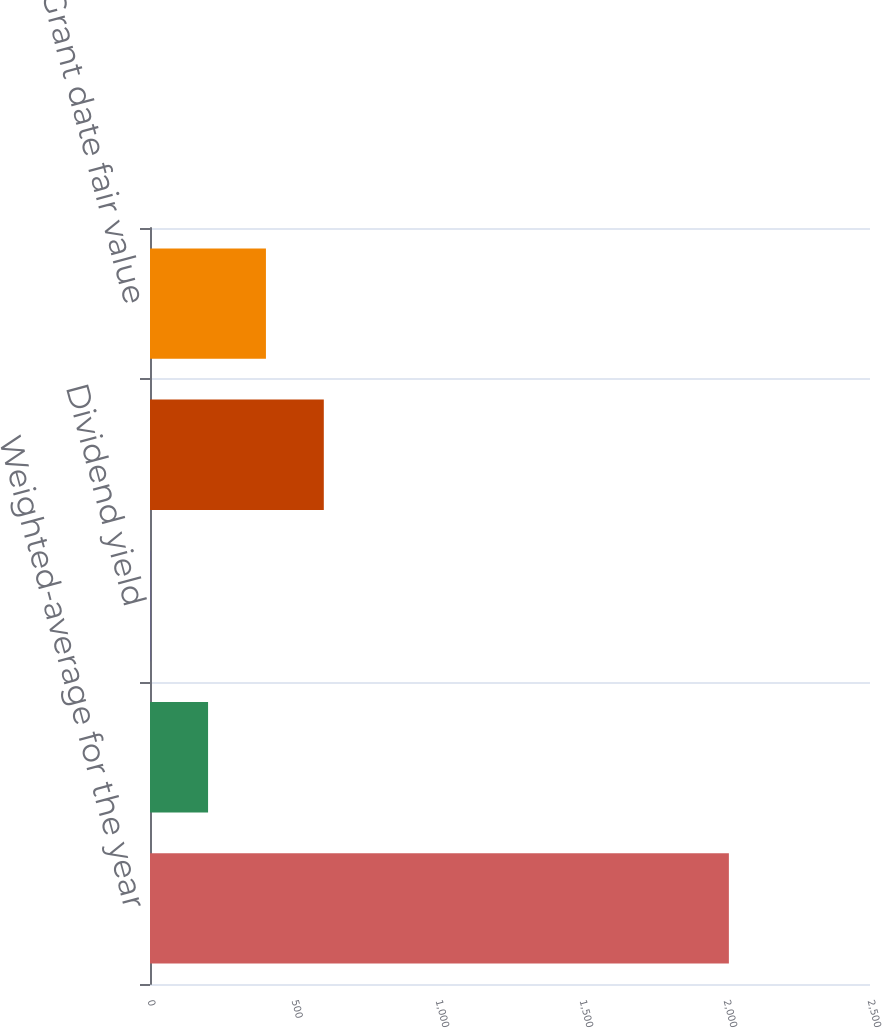Convert chart to OTSL. <chart><loc_0><loc_0><loc_500><loc_500><bar_chart><fcel>Weighted-average for the year<fcel>Risk-free interest rate<fcel>Dividend yield<fcel>Volatility<fcel>Grant date fair value<nl><fcel>2010<fcel>201.63<fcel>0.7<fcel>603.49<fcel>402.56<nl></chart> 